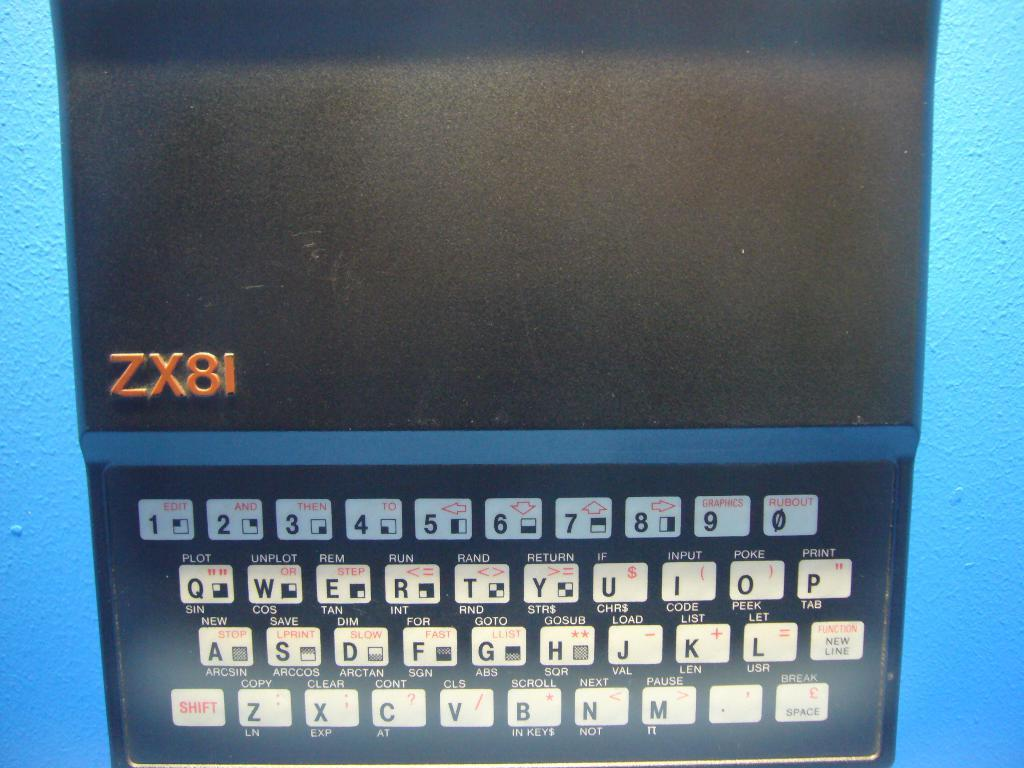<image>
Render a clear and concise summary of the photo. A powered down ZX81 mobile ddevice sitting on a blue floor. 